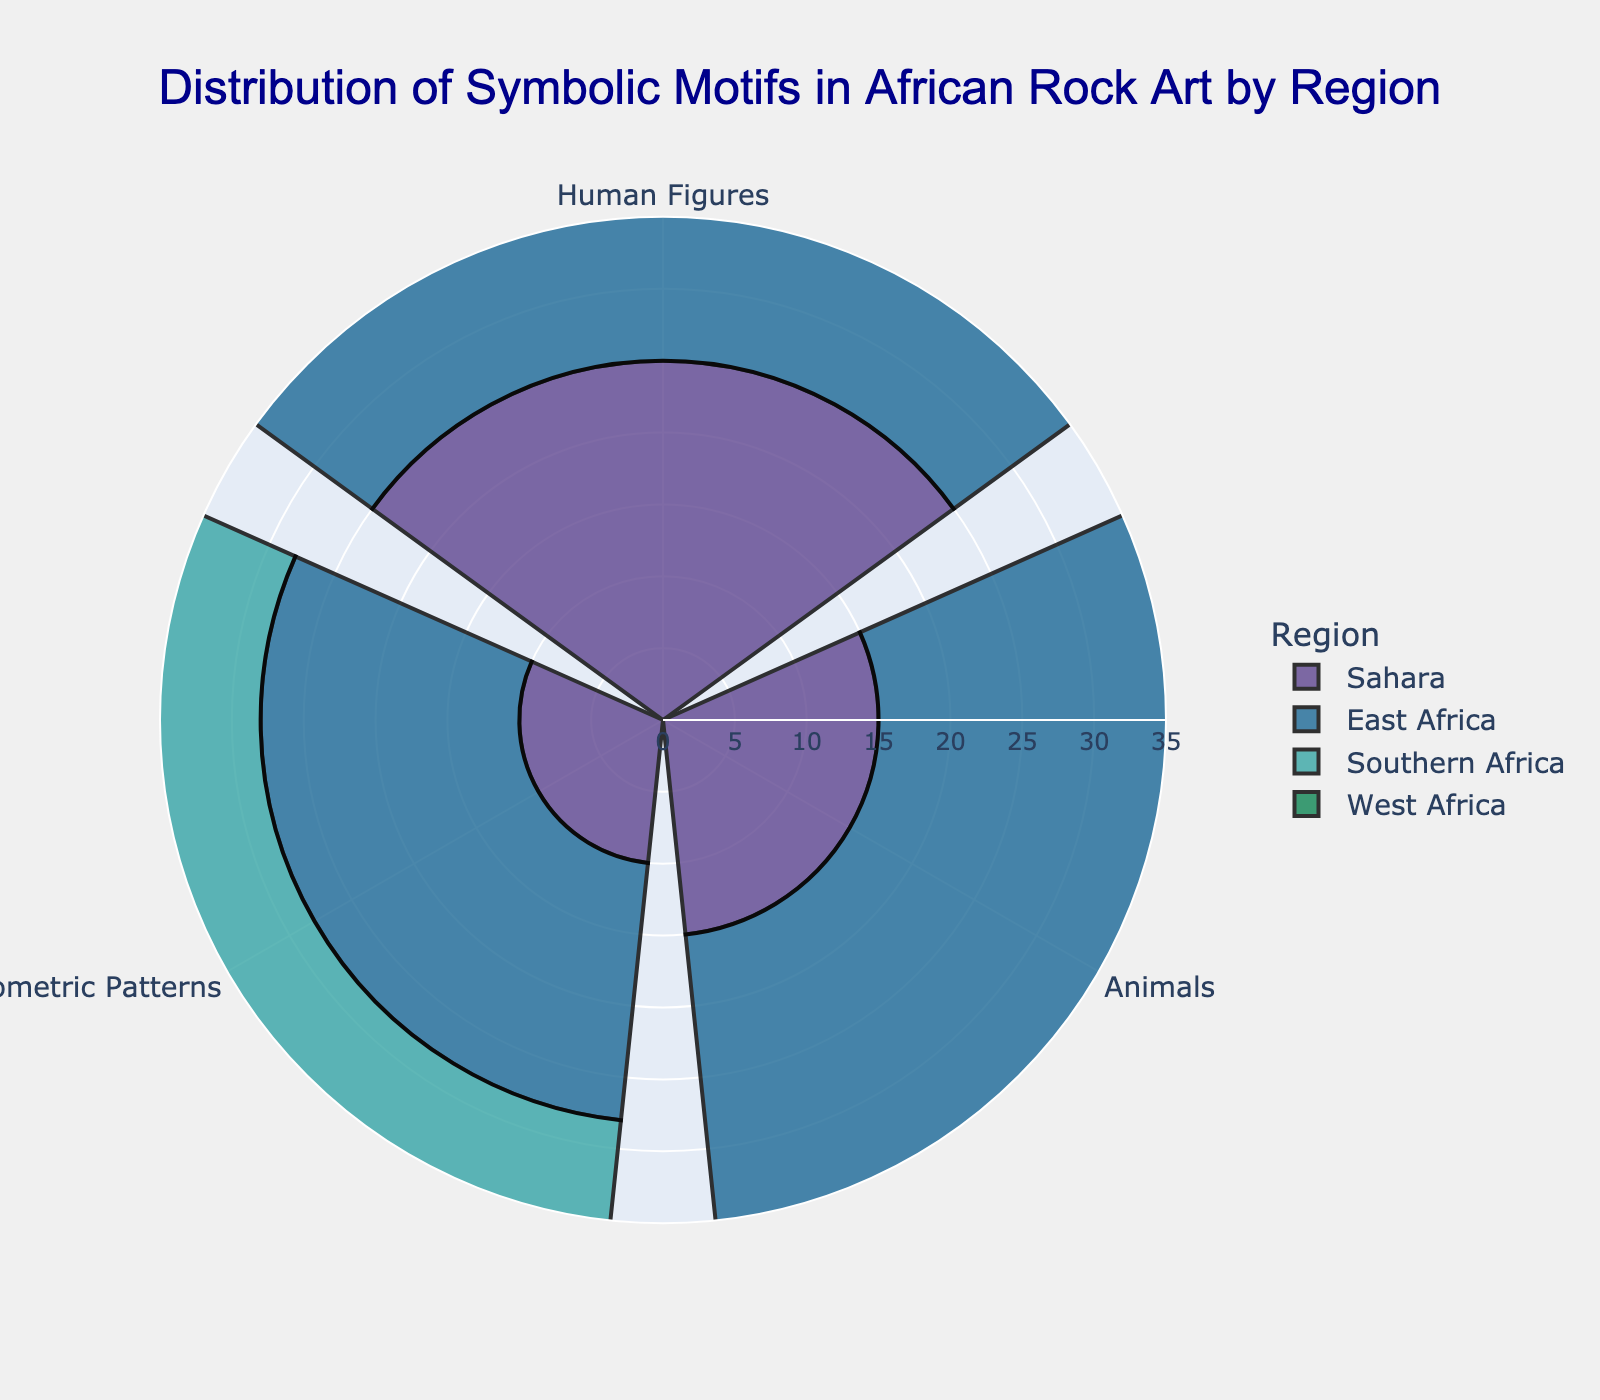What is the title of the figure? The title is often displayed at the top and typically describes the main focus or content of the figure. The title states, "Distribution of Symbolic Motifs in African Rock Art by Region".
Answer: Distribution of Symbolic Motifs in African Rock Art by Region Which region has the highest frequency of "Human Figures" motifs? To determine this, find the region with the longest bar segment for "Human Figures". Southern Africa has the highest frequency because its "Human Figures" segment extends further than the others.
Answer: Southern Africa Which region has the least frequent "Animals" motifs? By comparing the length of the "Animals" bars, one can see that Southern Africa has the shortest bar for "Animals", indicating the least frequency.
Answer: Southern Africa What is the total frequency of "Geometric Patterns" in all regions combined? Add the frequencies of "Geometric Patterns" across all regions: (Sahara: 10) + (East Africa: 18) + (Southern Africa: 20) + (West Africa: 12). The sum is 60.
Answer: 60 How does the frequency of "Human Figures" in West Africa compare to East Africa? Compare the lengths of the bars for "Human Figures" in West and East Africa. West Africa has 18, while East Africa has 20. Thus, East Africa has slightly more "Human Figures".
Answer: East Africa has more Is there a region where "Geometric Patterns" are more frequent than "Animals"? For each region, compare the "Geometric Patterns" and "Animals" frequencies. In Southern Africa, "Geometric Patterns" (20) have a higher frequency than "Animals" (10).
Answer: Southern Africa Which region shows the most balanced distribution among the three motifs? A balanced distribution implies that the frequencies of the three motifs are close to each other. East Africa has frequencies of Human Figures: 20, Animals: 22, and Geometric Patterns: 18, which are relatively close to each other.
Answer: East Africa What is the difference in the frequency of "Human Figures" between the Sahara and Southern Africa? Subtract the frequency of "Human Figures" in the Sahara (25) from that in Southern Africa (30). The difference is 5.
Answer: 5 How many motifs have a frequency of over 20 in Southern Africa? Examine each motif in Southern Africa: Human Figures (30), Animals (10), Geometric Patterns (20). Only "Human Figures" has a frequency over 20.
Answer: 1 In which region does "Animals" have the highest frequency? Identify the region with the longest "Animals" bar. East Africa has the highest frequency for "Animals" with a value of 22.
Answer: East Africa 